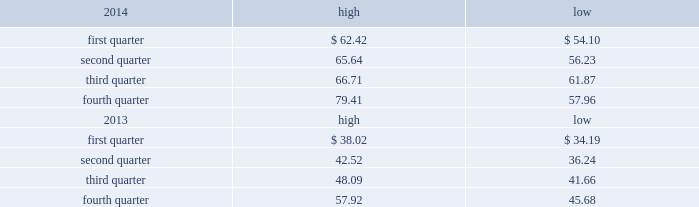Part ii item 5 .
Market for registrant 2019s common equity , related stockholder matters and issuer purchases of equity securities market price of and dividends on the registrant 2019s common equity and related stockholder matters market information .
Our class a common stock is quoted on the nasdaq global select market under the symbol 201cdish . 201d the high and low closing sale prices of our class a common stock during 2014 and 2013 on the nasdaq global select market ( as reported by nasdaq ) are set forth below. .
As of february 13 , 2015 , there were approximately 8208 holders of record of our class a common stock , not including stockholders who beneficially own class a common stock held in nominee or street name .
As of february 10 , 2015 , 213247004 of the 238435208 outstanding shares of our class b common stock were beneficially held by charles w .
Ergen , our chairman , and the remaining 25188204 were held in trusts established by mr .
Ergen for the benefit of his family .
There is currently no trading market for our class b common stock .
Dividends .
On december 28 , 2012 , we paid a cash dividend of $ 1.00 per share , or approximately $ 453 million , on our outstanding class a and class b common stock to stockholders of record at the close of business on december 14 , 2012 .
While we currently do not intend to declare additional dividends on our common stock , we may elect to do so from time to time .
Payment of any future dividends will depend upon our earnings and capital requirements , restrictions in our debt facilities , and other factors the board of directors considers appropriate .
We currently intend to retain our earnings , if any , to support future growth and expansion , although we may repurchase shares of our common stock from time to time .
See further discussion under 201citem 7 .
Management 2019s discussion and analysis of financial condition and results of operations 2013 liquidity and capital resources 201d in this annual report on form 10-k .
Securities authorized for issuance under equity compensation plans .
See 201citem 12 .
Security ownership of certain beneficial owners and management and related stockholder matters 201d in this annual report on form 10-k. .
What was the average stock price for the fourth quarter of 2014? 
Computations: table_average(fourth quarter, none)
Answer: 51.8. Part ii item 5 .
Market for registrant 2019s common equity , related stockholder matters and issuer purchases of equity securities market price of and dividends on the registrant 2019s common equity and related stockholder matters market information .
Our class a common stock is quoted on the nasdaq global select market under the symbol 201cdish . 201d the high and low closing sale prices of our class a common stock during 2014 and 2013 on the nasdaq global select market ( as reported by nasdaq ) are set forth below. .
As of february 13 , 2015 , there were approximately 8208 holders of record of our class a common stock , not including stockholders who beneficially own class a common stock held in nominee or street name .
As of february 10 , 2015 , 213247004 of the 238435208 outstanding shares of our class b common stock were beneficially held by charles w .
Ergen , our chairman , and the remaining 25188204 were held in trusts established by mr .
Ergen for the benefit of his family .
There is currently no trading market for our class b common stock .
Dividends .
On december 28 , 2012 , we paid a cash dividend of $ 1.00 per share , or approximately $ 453 million , on our outstanding class a and class b common stock to stockholders of record at the close of business on december 14 , 2012 .
While we currently do not intend to declare additional dividends on our common stock , we may elect to do so from time to time .
Payment of any future dividends will depend upon our earnings and capital requirements , restrictions in our debt facilities , and other factors the board of directors considers appropriate .
We currently intend to retain our earnings , if any , to support future growth and expansion , although we may repurchase shares of our common stock from time to time .
See further discussion under 201citem 7 .
Management 2019s discussion and analysis of financial condition and results of operations 2013 liquidity and capital resources 201d in this annual report on form 10-k .
Securities authorized for issuance under equity compensation plans .
See 201citem 12 .
Security ownership of certain beneficial owners and management and related stockholder matters 201d in this annual report on form 10-k. .
What portion of the outstanding shares of our class b common stock were held by the chairman? 
Computations: (213247004 / 238435208)
Answer: 0.89436. 